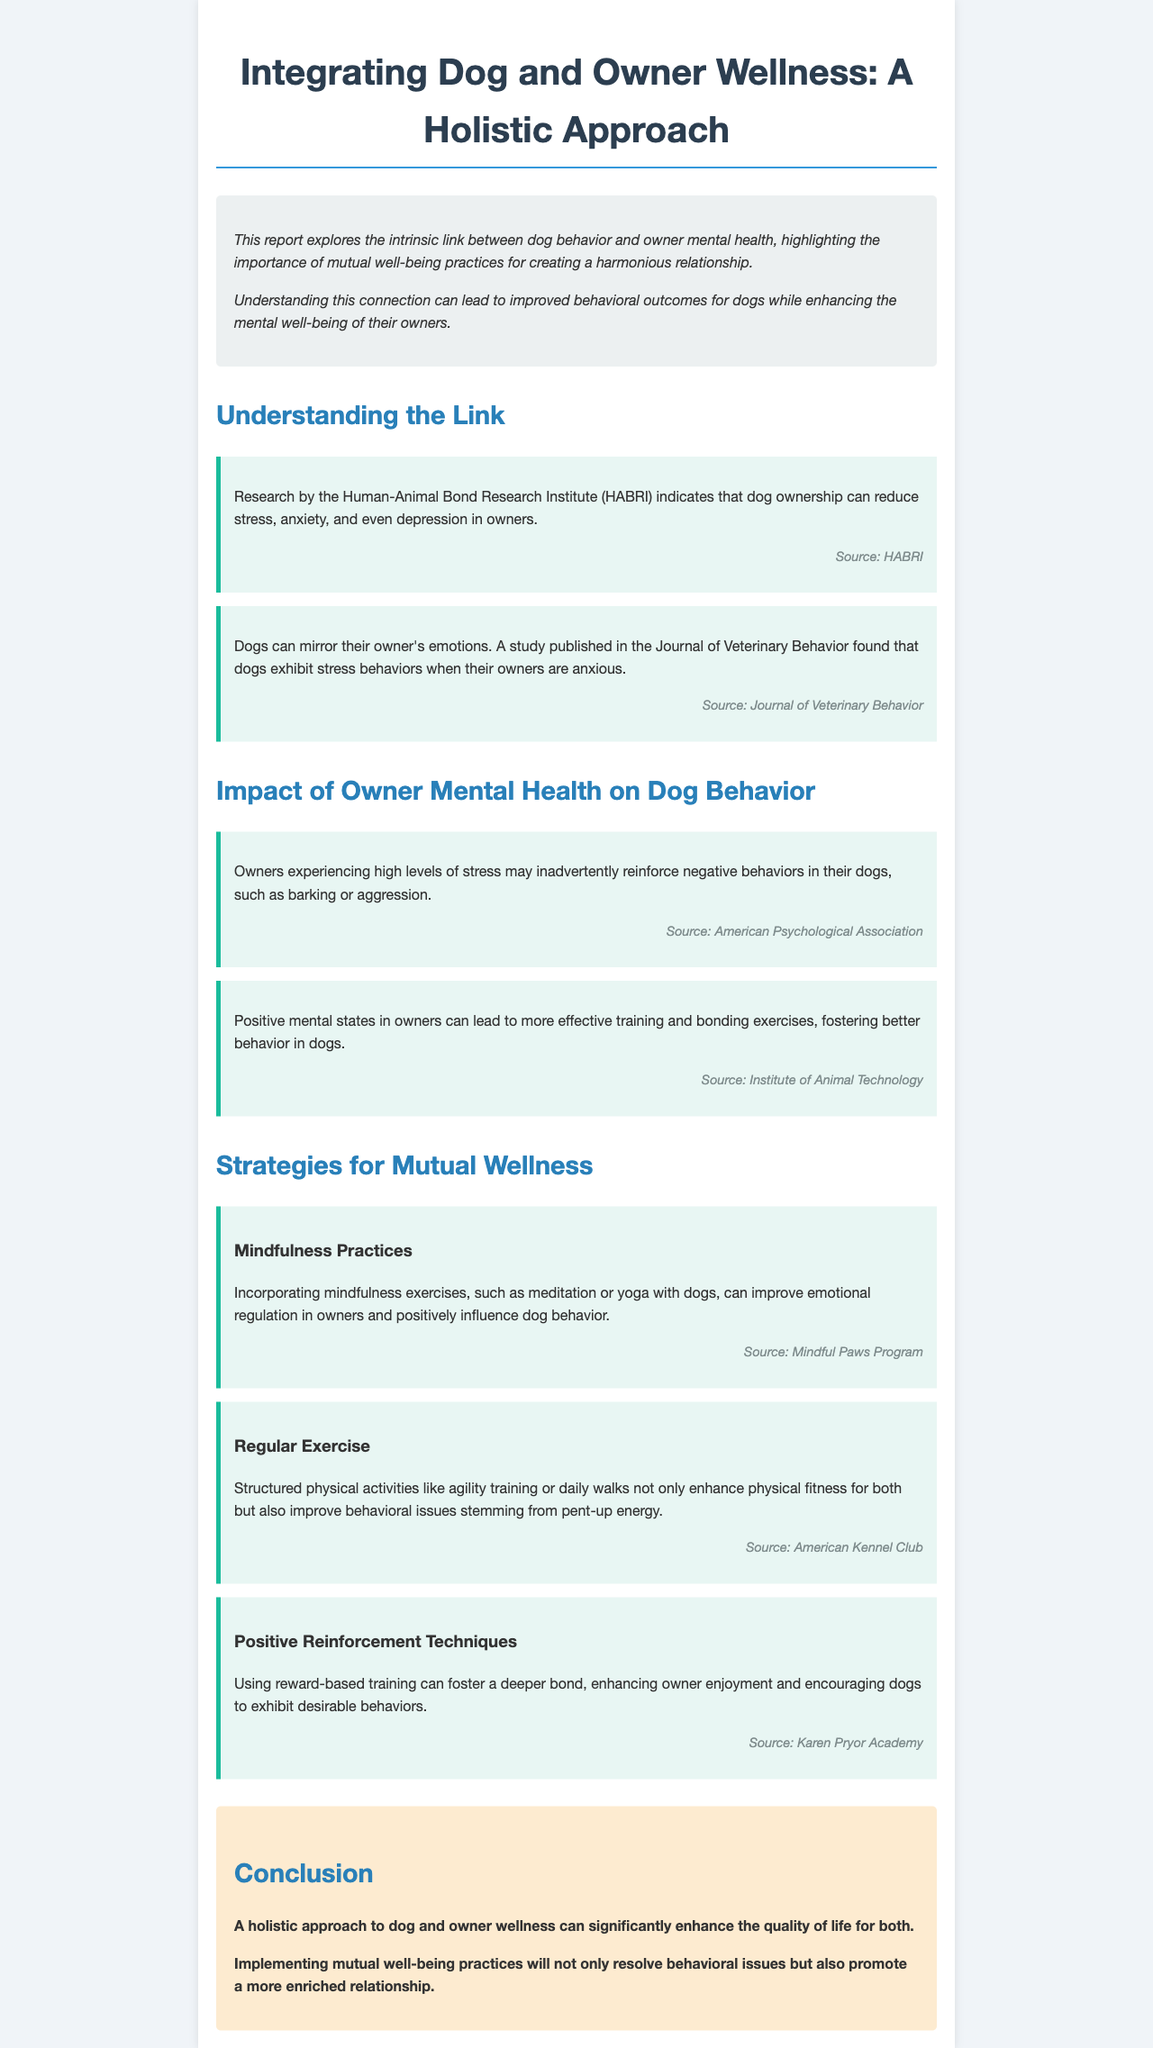What is the title of the report? The title of the report is stated at the top of the document.
Answer: Integrating Dog and Owner Wellness: A Holistic Approach What does the introduction emphasize? The introduction highlights the importance of mutual well-being practices for a harmonious relationship.
Answer: Mutual well-being practices Which organization conducted research indicating reduced stress in dog owners? The document cites research by a specific organization related to stress reduction in dog owners.
Answer: Human-Animal Bond Research Institute (HABRI) What is a suggested practice for improving emotional regulation in owners? The report mentions specific exercises that can enhance emotional regulation.
Answer: Mindfulness exercises How does high stress in owners affect their dogs? The document explains the impact of owner stress on dog behavior.
Answer: Reinforce negative behaviors What type of training is recommended to enhance the bond between dogs and owners? The report suggests a training method that uses a specific approach to improve the bond.
Answer: Positive reinforcement techniques What effect does regular exercise have on dog behavior? The document provides insights on the benefits of structured physical activities for dogs.
Answer: Improve behavioral issues What is the conclusion of the report? The conclusion summarizes the overall findings presented in the document.
Answer: Enhance the quality of life for both 